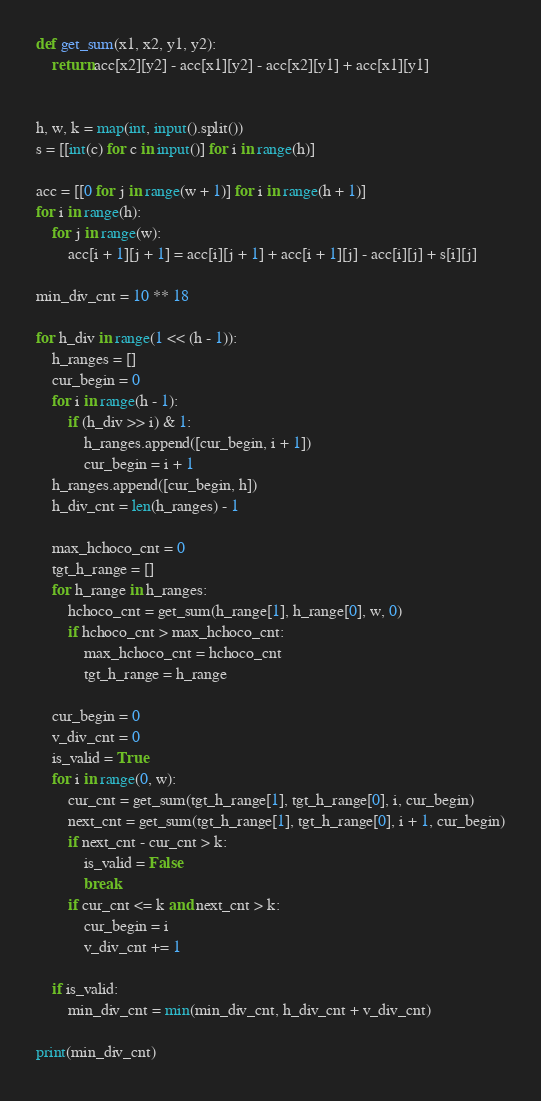<code> <loc_0><loc_0><loc_500><loc_500><_Python_>def get_sum(x1, x2, y1, y2):
    return acc[x2][y2] - acc[x1][y2] - acc[x2][y1] + acc[x1][y1]


h, w, k = map(int, input().split())
s = [[int(c) for c in input()] for i in range(h)]

acc = [[0 for j in range(w + 1)] for i in range(h + 1)]
for i in range(h):
    for j in range(w):
        acc[i + 1][j + 1] = acc[i][j + 1] + acc[i + 1][j] - acc[i][j] + s[i][j]

min_div_cnt = 10 ** 18

for h_div in range(1 << (h - 1)):
    h_ranges = []
    cur_begin = 0
    for i in range(h - 1):
        if (h_div >> i) & 1:
            h_ranges.append([cur_begin, i + 1])
            cur_begin = i + 1
    h_ranges.append([cur_begin, h])
    h_div_cnt = len(h_ranges) - 1

    max_hchoco_cnt = 0
    tgt_h_range = []
    for h_range in h_ranges:
        hchoco_cnt = get_sum(h_range[1], h_range[0], w, 0)
        if hchoco_cnt > max_hchoco_cnt:
            max_hchoco_cnt = hchoco_cnt
            tgt_h_range = h_range

    cur_begin = 0
    v_div_cnt = 0
    is_valid = True
    for i in range(0, w):
        cur_cnt = get_sum(tgt_h_range[1], tgt_h_range[0], i, cur_begin)
        next_cnt = get_sum(tgt_h_range[1], tgt_h_range[0], i + 1, cur_begin)
        if next_cnt - cur_cnt > k:
            is_valid = False
            break
        if cur_cnt <= k and next_cnt > k:
            cur_begin = i
            v_div_cnt += 1

    if is_valid:
        min_div_cnt = min(min_div_cnt, h_div_cnt + v_div_cnt)

print(min_div_cnt)
</code> 